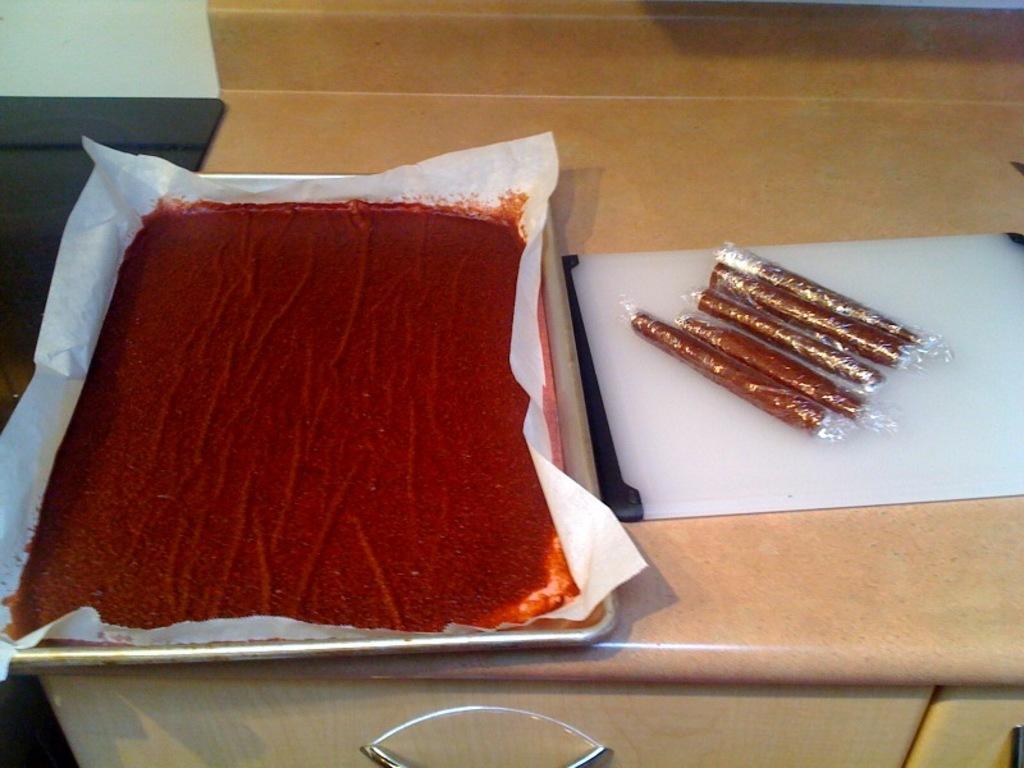Please provide a concise description of this image. In this image we can see a red colored food item which is kept in a tray, and some food items are made rolls and kept on a tray. A table is there here. 